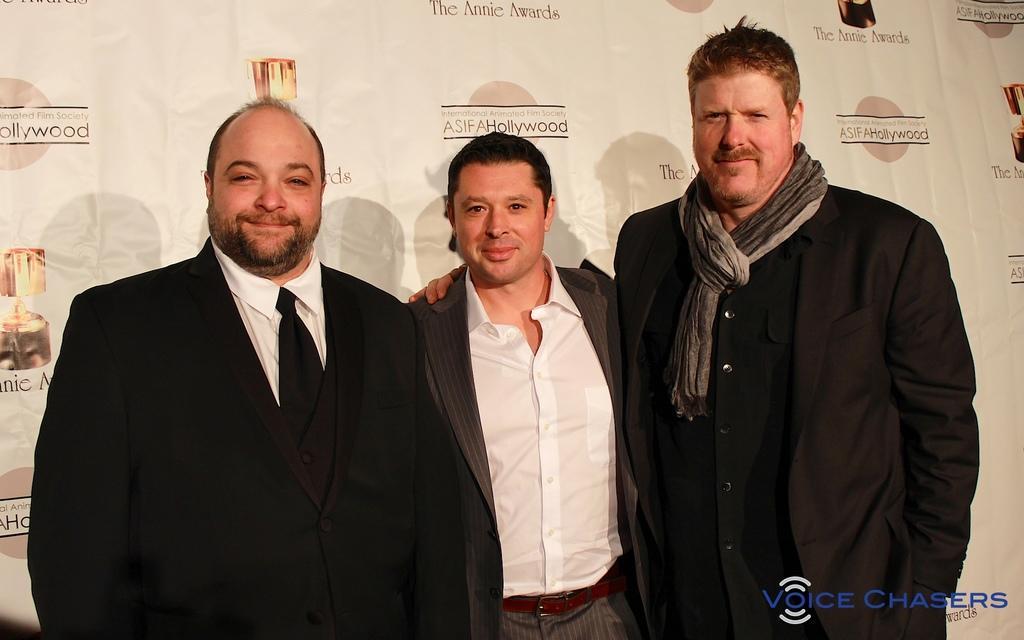Can you describe this image briefly? In this picture there are three persons standing and smiling. At the back there is a hoarding and there is a text on the hoarding and there are shadows of the three persons on the hoarding. In the bottom right there is a text. 